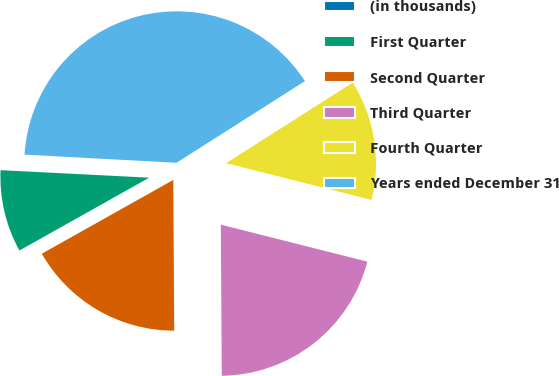Convert chart. <chart><loc_0><loc_0><loc_500><loc_500><pie_chart><fcel>(in thousands)<fcel>First Quarter<fcel>Second Quarter<fcel>Third Quarter<fcel>Fourth Quarter<fcel>Years ended December 31<nl><fcel>0.05%<fcel>8.94%<fcel>16.96%<fcel>20.96%<fcel>12.95%<fcel>40.13%<nl></chart> 